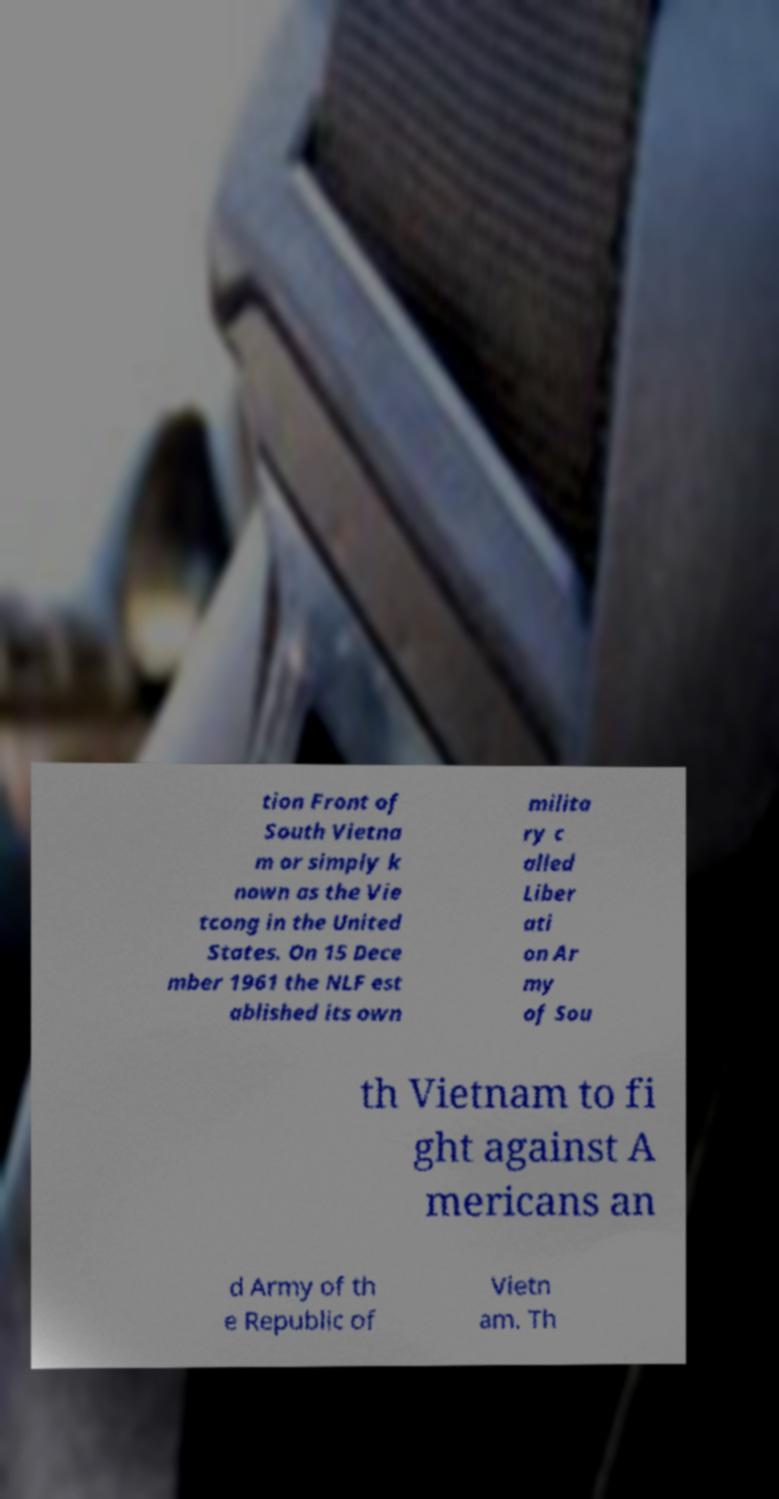Can you read and provide the text displayed in the image?This photo seems to have some interesting text. Can you extract and type it out for me? tion Front of South Vietna m or simply k nown as the Vie tcong in the United States. On 15 Dece mber 1961 the NLF est ablished its own milita ry c alled Liber ati on Ar my of Sou th Vietnam to fi ght against A mericans an d Army of th e Republic of Vietn am. Th 